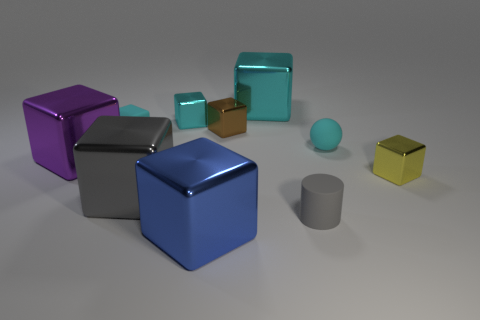How many large cyan shiny objects are in front of the brown metallic object that is behind the ball?
Your response must be concise. 0. There is a cyan matte object that is behind the cyan object that is to the right of the gray matte thing; is there a yellow thing that is right of it?
Make the answer very short. Yes. There is a gray thing that is the same shape as the tiny yellow thing; what material is it?
Make the answer very short. Metal. Is there anything else that has the same material as the tiny gray cylinder?
Your answer should be compact. Yes. Does the large gray cube have the same material as the small block that is in front of the big purple cube?
Give a very brief answer. Yes. The small matte thing left of the big metal cube that is in front of the gray metallic thing is what shape?
Offer a very short reply. Cube. How many tiny things are cyan matte balls or cyan metallic things?
Give a very brief answer. 2. What number of tiny yellow metallic objects have the same shape as the tiny gray matte thing?
Your answer should be compact. 0. Does the big cyan metal thing have the same shape as the small matte thing that is in front of the large purple object?
Provide a short and direct response. No. There is a cyan rubber cube; what number of gray things are to the left of it?
Offer a terse response. 0. 